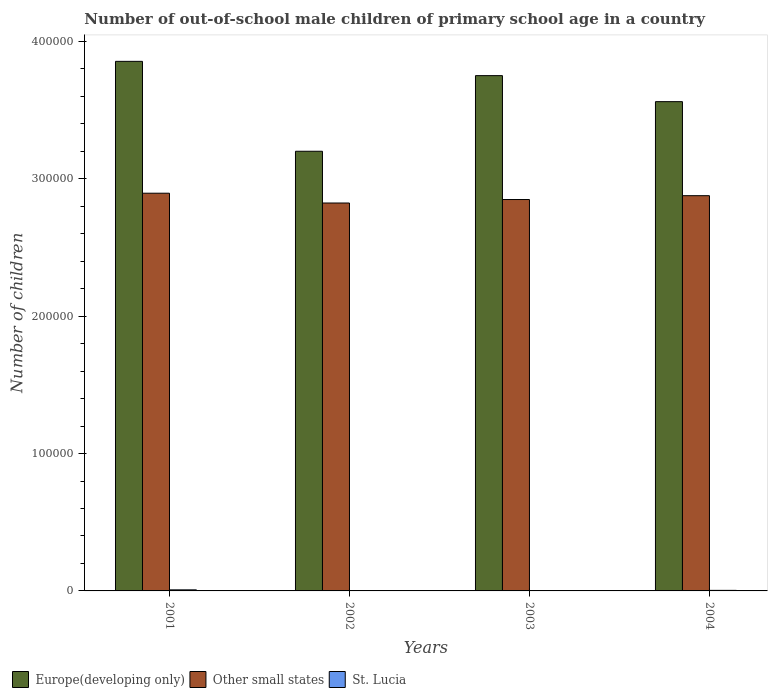Are the number of bars on each tick of the X-axis equal?
Make the answer very short. Yes. What is the number of out-of-school male children in Other small states in 2004?
Provide a short and direct response. 2.88e+05. Across all years, what is the maximum number of out-of-school male children in Europe(developing only)?
Your response must be concise. 3.85e+05. What is the total number of out-of-school male children in Other small states in the graph?
Ensure brevity in your answer.  1.14e+06. What is the difference between the number of out-of-school male children in Other small states in 2001 and that in 2004?
Your answer should be compact. 1800. What is the difference between the number of out-of-school male children in Other small states in 2001 and the number of out-of-school male children in St. Lucia in 2004?
Your response must be concise. 2.89e+05. What is the average number of out-of-school male children in Other small states per year?
Give a very brief answer. 2.86e+05. In the year 2002, what is the difference between the number of out-of-school male children in Other small states and number of out-of-school male children in Europe(developing only)?
Offer a very short reply. -3.77e+04. In how many years, is the number of out-of-school male children in Europe(developing only) greater than 280000?
Make the answer very short. 4. What is the ratio of the number of out-of-school male children in Europe(developing only) in 2001 to that in 2004?
Keep it short and to the point. 1.08. What is the difference between the highest and the second highest number of out-of-school male children in Other small states?
Your answer should be very brief. 1800. What is the difference between the highest and the lowest number of out-of-school male children in Other small states?
Ensure brevity in your answer.  7131. In how many years, is the number of out-of-school male children in St. Lucia greater than the average number of out-of-school male children in St. Lucia taken over all years?
Give a very brief answer. 2. What does the 3rd bar from the left in 2003 represents?
Your answer should be very brief. St. Lucia. What does the 3rd bar from the right in 2001 represents?
Provide a succinct answer. Europe(developing only). How many bars are there?
Give a very brief answer. 12. Are all the bars in the graph horizontal?
Your answer should be compact. No. Does the graph contain any zero values?
Ensure brevity in your answer.  No. Does the graph contain grids?
Your answer should be compact. No. Where does the legend appear in the graph?
Ensure brevity in your answer.  Bottom left. How many legend labels are there?
Make the answer very short. 3. How are the legend labels stacked?
Offer a terse response. Horizontal. What is the title of the graph?
Ensure brevity in your answer.  Number of out-of-school male children of primary school age in a country. What is the label or title of the X-axis?
Provide a succinct answer. Years. What is the label or title of the Y-axis?
Offer a terse response. Number of children. What is the Number of children of Europe(developing only) in 2001?
Your answer should be compact. 3.85e+05. What is the Number of children in Other small states in 2001?
Give a very brief answer. 2.90e+05. What is the Number of children of St. Lucia in 2001?
Provide a short and direct response. 777. What is the Number of children in Europe(developing only) in 2002?
Your answer should be very brief. 3.20e+05. What is the Number of children in Other small states in 2002?
Your answer should be very brief. 2.82e+05. What is the Number of children of Europe(developing only) in 2003?
Keep it short and to the point. 3.75e+05. What is the Number of children of Other small states in 2003?
Offer a terse response. 2.85e+05. What is the Number of children of St. Lucia in 2003?
Your response must be concise. 202. What is the Number of children of Europe(developing only) in 2004?
Offer a very short reply. 3.56e+05. What is the Number of children of Other small states in 2004?
Keep it short and to the point. 2.88e+05. What is the Number of children of St. Lucia in 2004?
Keep it short and to the point. 406. Across all years, what is the maximum Number of children of Europe(developing only)?
Offer a very short reply. 3.85e+05. Across all years, what is the maximum Number of children in Other small states?
Your answer should be very brief. 2.90e+05. Across all years, what is the maximum Number of children of St. Lucia?
Give a very brief answer. 777. Across all years, what is the minimum Number of children in Europe(developing only)?
Ensure brevity in your answer.  3.20e+05. Across all years, what is the minimum Number of children of Other small states?
Your answer should be compact. 2.82e+05. What is the total Number of children of Europe(developing only) in the graph?
Offer a terse response. 1.44e+06. What is the total Number of children of Other small states in the graph?
Make the answer very short. 1.14e+06. What is the total Number of children of St. Lucia in the graph?
Make the answer very short. 1443. What is the difference between the Number of children of Europe(developing only) in 2001 and that in 2002?
Offer a terse response. 6.54e+04. What is the difference between the Number of children of Other small states in 2001 and that in 2002?
Make the answer very short. 7131. What is the difference between the Number of children of St. Lucia in 2001 and that in 2002?
Your answer should be compact. 719. What is the difference between the Number of children in Europe(developing only) in 2001 and that in 2003?
Provide a short and direct response. 1.04e+04. What is the difference between the Number of children in Other small states in 2001 and that in 2003?
Keep it short and to the point. 4598. What is the difference between the Number of children of St. Lucia in 2001 and that in 2003?
Make the answer very short. 575. What is the difference between the Number of children of Europe(developing only) in 2001 and that in 2004?
Give a very brief answer. 2.93e+04. What is the difference between the Number of children of Other small states in 2001 and that in 2004?
Offer a very short reply. 1800. What is the difference between the Number of children of St. Lucia in 2001 and that in 2004?
Give a very brief answer. 371. What is the difference between the Number of children of Europe(developing only) in 2002 and that in 2003?
Make the answer very short. -5.51e+04. What is the difference between the Number of children in Other small states in 2002 and that in 2003?
Make the answer very short. -2533. What is the difference between the Number of children of St. Lucia in 2002 and that in 2003?
Your response must be concise. -144. What is the difference between the Number of children in Europe(developing only) in 2002 and that in 2004?
Ensure brevity in your answer.  -3.61e+04. What is the difference between the Number of children in Other small states in 2002 and that in 2004?
Give a very brief answer. -5331. What is the difference between the Number of children in St. Lucia in 2002 and that in 2004?
Make the answer very short. -348. What is the difference between the Number of children in Europe(developing only) in 2003 and that in 2004?
Your response must be concise. 1.89e+04. What is the difference between the Number of children of Other small states in 2003 and that in 2004?
Ensure brevity in your answer.  -2798. What is the difference between the Number of children of St. Lucia in 2003 and that in 2004?
Your response must be concise. -204. What is the difference between the Number of children in Europe(developing only) in 2001 and the Number of children in Other small states in 2002?
Your response must be concise. 1.03e+05. What is the difference between the Number of children of Europe(developing only) in 2001 and the Number of children of St. Lucia in 2002?
Offer a terse response. 3.85e+05. What is the difference between the Number of children of Other small states in 2001 and the Number of children of St. Lucia in 2002?
Your response must be concise. 2.89e+05. What is the difference between the Number of children in Europe(developing only) in 2001 and the Number of children in Other small states in 2003?
Offer a terse response. 1.01e+05. What is the difference between the Number of children of Europe(developing only) in 2001 and the Number of children of St. Lucia in 2003?
Offer a very short reply. 3.85e+05. What is the difference between the Number of children of Other small states in 2001 and the Number of children of St. Lucia in 2003?
Provide a succinct answer. 2.89e+05. What is the difference between the Number of children of Europe(developing only) in 2001 and the Number of children of Other small states in 2004?
Give a very brief answer. 9.78e+04. What is the difference between the Number of children in Europe(developing only) in 2001 and the Number of children in St. Lucia in 2004?
Make the answer very short. 3.85e+05. What is the difference between the Number of children of Other small states in 2001 and the Number of children of St. Lucia in 2004?
Ensure brevity in your answer.  2.89e+05. What is the difference between the Number of children of Europe(developing only) in 2002 and the Number of children of Other small states in 2003?
Make the answer very short. 3.51e+04. What is the difference between the Number of children of Europe(developing only) in 2002 and the Number of children of St. Lucia in 2003?
Your answer should be compact. 3.20e+05. What is the difference between the Number of children of Other small states in 2002 and the Number of children of St. Lucia in 2003?
Provide a succinct answer. 2.82e+05. What is the difference between the Number of children of Europe(developing only) in 2002 and the Number of children of Other small states in 2004?
Offer a terse response. 3.23e+04. What is the difference between the Number of children in Europe(developing only) in 2002 and the Number of children in St. Lucia in 2004?
Your answer should be very brief. 3.20e+05. What is the difference between the Number of children in Other small states in 2002 and the Number of children in St. Lucia in 2004?
Your answer should be very brief. 2.82e+05. What is the difference between the Number of children of Europe(developing only) in 2003 and the Number of children of Other small states in 2004?
Provide a short and direct response. 8.74e+04. What is the difference between the Number of children in Europe(developing only) in 2003 and the Number of children in St. Lucia in 2004?
Keep it short and to the point. 3.75e+05. What is the difference between the Number of children of Other small states in 2003 and the Number of children of St. Lucia in 2004?
Offer a very short reply. 2.84e+05. What is the average Number of children in Europe(developing only) per year?
Your response must be concise. 3.59e+05. What is the average Number of children of Other small states per year?
Offer a terse response. 2.86e+05. What is the average Number of children of St. Lucia per year?
Ensure brevity in your answer.  360.75. In the year 2001, what is the difference between the Number of children in Europe(developing only) and Number of children in Other small states?
Your answer should be compact. 9.60e+04. In the year 2001, what is the difference between the Number of children in Europe(developing only) and Number of children in St. Lucia?
Your response must be concise. 3.85e+05. In the year 2001, what is the difference between the Number of children of Other small states and Number of children of St. Lucia?
Give a very brief answer. 2.89e+05. In the year 2002, what is the difference between the Number of children of Europe(developing only) and Number of children of Other small states?
Provide a short and direct response. 3.77e+04. In the year 2002, what is the difference between the Number of children of Europe(developing only) and Number of children of St. Lucia?
Keep it short and to the point. 3.20e+05. In the year 2002, what is the difference between the Number of children in Other small states and Number of children in St. Lucia?
Keep it short and to the point. 2.82e+05. In the year 2003, what is the difference between the Number of children of Europe(developing only) and Number of children of Other small states?
Offer a terse response. 9.02e+04. In the year 2003, what is the difference between the Number of children in Europe(developing only) and Number of children in St. Lucia?
Ensure brevity in your answer.  3.75e+05. In the year 2003, what is the difference between the Number of children of Other small states and Number of children of St. Lucia?
Ensure brevity in your answer.  2.85e+05. In the year 2004, what is the difference between the Number of children of Europe(developing only) and Number of children of Other small states?
Offer a terse response. 6.84e+04. In the year 2004, what is the difference between the Number of children of Europe(developing only) and Number of children of St. Lucia?
Provide a short and direct response. 3.56e+05. In the year 2004, what is the difference between the Number of children of Other small states and Number of children of St. Lucia?
Make the answer very short. 2.87e+05. What is the ratio of the Number of children in Europe(developing only) in 2001 to that in 2002?
Your answer should be very brief. 1.2. What is the ratio of the Number of children of Other small states in 2001 to that in 2002?
Provide a short and direct response. 1.03. What is the ratio of the Number of children of St. Lucia in 2001 to that in 2002?
Provide a succinct answer. 13.4. What is the ratio of the Number of children of Europe(developing only) in 2001 to that in 2003?
Offer a very short reply. 1.03. What is the ratio of the Number of children in Other small states in 2001 to that in 2003?
Your response must be concise. 1.02. What is the ratio of the Number of children in St. Lucia in 2001 to that in 2003?
Provide a succinct answer. 3.85. What is the ratio of the Number of children of Europe(developing only) in 2001 to that in 2004?
Keep it short and to the point. 1.08. What is the ratio of the Number of children of Other small states in 2001 to that in 2004?
Offer a terse response. 1.01. What is the ratio of the Number of children in St. Lucia in 2001 to that in 2004?
Your response must be concise. 1.91. What is the ratio of the Number of children of Europe(developing only) in 2002 to that in 2003?
Provide a short and direct response. 0.85. What is the ratio of the Number of children of St. Lucia in 2002 to that in 2003?
Provide a short and direct response. 0.29. What is the ratio of the Number of children of Europe(developing only) in 2002 to that in 2004?
Keep it short and to the point. 0.9. What is the ratio of the Number of children in Other small states in 2002 to that in 2004?
Provide a short and direct response. 0.98. What is the ratio of the Number of children of St. Lucia in 2002 to that in 2004?
Your answer should be compact. 0.14. What is the ratio of the Number of children of Europe(developing only) in 2003 to that in 2004?
Your response must be concise. 1.05. What is the ratio of the Number of children of Other small states in 2003 to that in 2004?
Offer a terse response. 0.99. What is the ratio of the Number of children in St. Lucia in 2003 to that in 2004?
Your answer should be compact. 0.5. What is the difference between the highest and the second highest Number of children of Europe(developing only)?
Provide a succinct answer. 1.04e+04. What is the difference between the highest and the second highest Number of children of Other small states?
Offer a very short reply. 1800. What is the difference between the highest and the second highest Number of children of St. Lucia?
Give a very brief answer. 371. What is the difference between the highest and the lowest Number of children in Europe(developing only)?
Give a very brief answer. 6.54e+04. What is the difference between the highest and the lowest Number of children of Other small states?
Offer a very short reply. 7131. What is the difference between the highest and the lowest Number of children in St. Lucia?
Offer a very short reply. 719. 